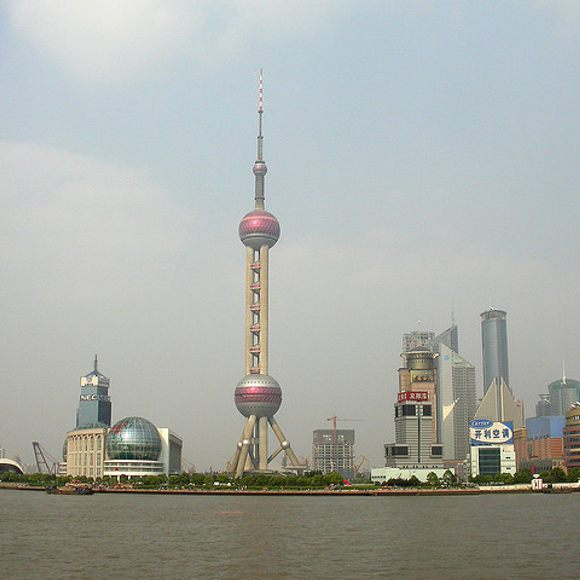Can you use your imagination to tell me what this tower could be in a fantasy world? Absolutely! In a fantasy world, the Oriental Pearl Tower could be a mystical Magi’s Lair known as the ‘Celestial Spire of Aetheria.’ This grand tower isn’t just an architectural marvel but a conduit of ancient magic. At night, the spheres of the tower glow with an ethereal light, pulsating with magical energy drawn from the cosmos. The largest sphere in the middle serves as a sanctuary for the Grand Magi, who oversees the balance of magic throughout the realm. The spire at the top channels celestial energy, making it a beacon for magical creatures and beings seeking wisdom or refuge. The body of water surrounding the spire is enchanted, inhabited by mythical water spirits that protect the land from dark forces. To those who dare to visit, the tower reveals paths to other realms, kept secret and sacred. The city below is a vibrant hub where magic and mortal life coexist, creating a unique society harmonized by ancient enchantments and modern wonders. 